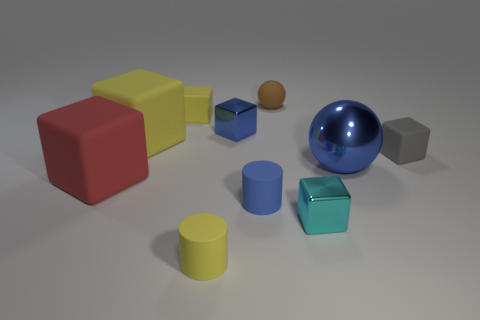Subtract all tiny yellow rubber blocks. How many blocks are left? 5 Subtract all purple balls. How many yellow cubes are left? 2 Subtract all gray cubes. How many cubes are left? 5 Subtract all brown cubes. Subtract all red cylinders. How many cubes are left? 6 Add 5 gray cubes. How many gray cubes exist? 6 Subtract 0 yellow spheres. How many objects are left? 10 Subtract all blocks. How many objects are left? 4 Subtract all tiny brown balls. Subtract all big blue shiny balls. How many objects are left? 8 Add 2 small matte spheres. How many small matte spheres are left? 3 